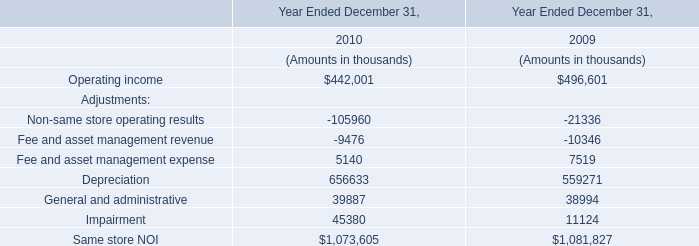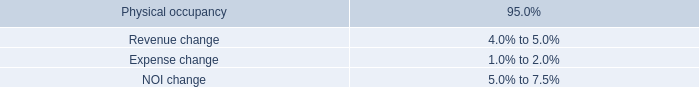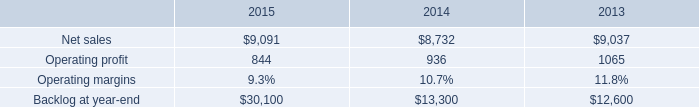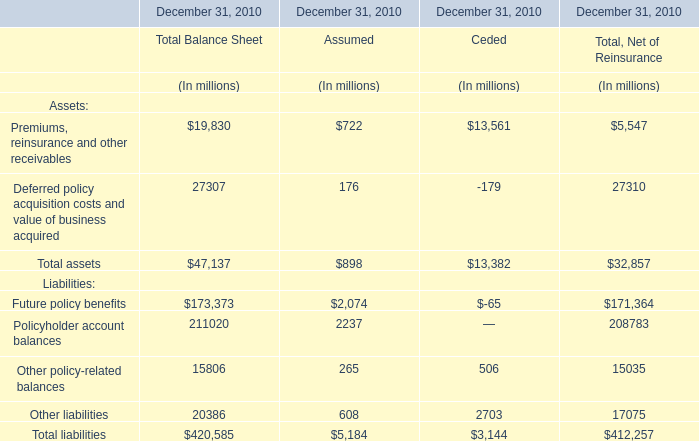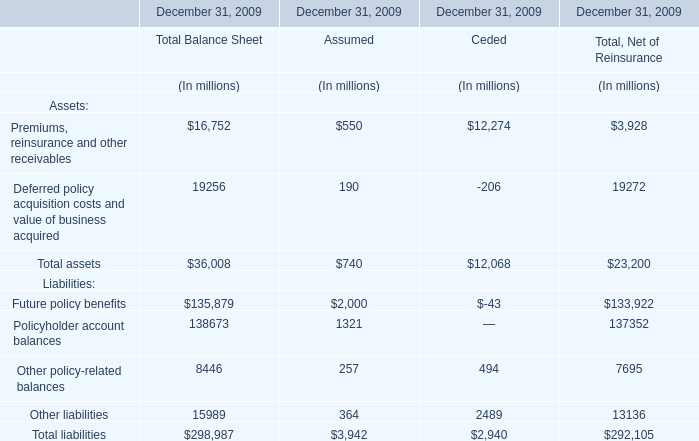Which element makes up more than 20% of the total for Assumed in 2010 ? 
Answer: Future policy benefits, Policyholder account balances. 